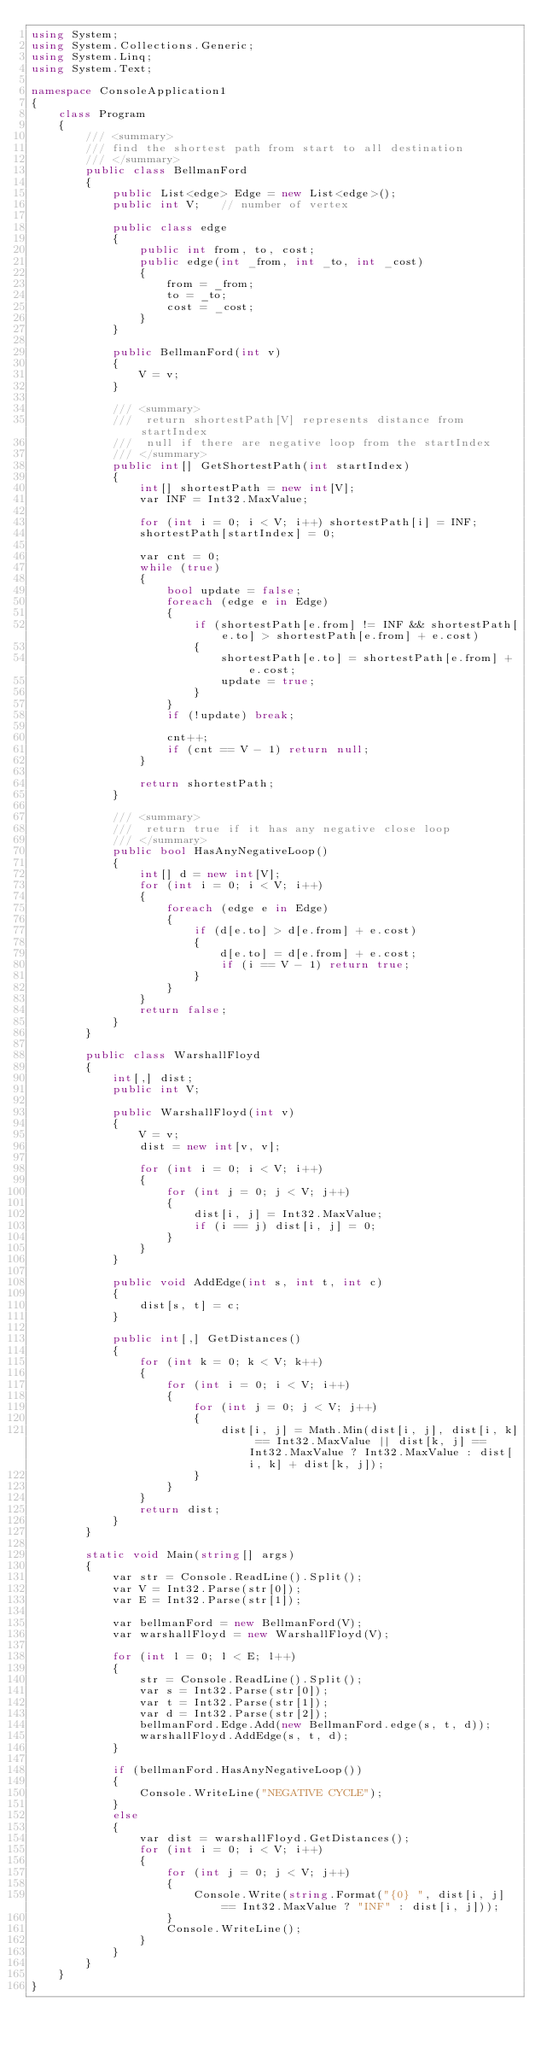<code> <loc_0><loc_0><loc_500><loc_500><_C#_>using System;
using System.Collections.Generic;
using System.Linq;
using System.Text;

namespace ConsoleApplication1
{
    class Program
    {
        /// <summary>
        /// find the shortest path from start to all destination
        /// </summary>
        public class BellmanFord
        {
            public List<edge> Edge = new List<edge>();
            public int V;   // number of vertex

            public class edge
            {
                public int from, to, cost;
                public edge(int _from, int _to, int _cost)
                {
                    from = _from;
                    to = _to;
                    cost = _cost;
                }
            }

            public BellmanFord(int v)
            {
                V = v;
            }

            /// <summary>
            ///  return shortestPath[V] represents distance from startIndex
            ///  null if there are negative loop from the startIndex
            /// </summary>
            public int[] GetShortestPath(int startIndex)
            {
                int[] shortestPath = new int[V];
                var INF = Int32.MaxValue;

                for (int i = 0; i < V; i++) shortestPath[i] = INF;
                shortestPath[startIndex] = 0;

                var cnt = 0;
                while (true)
                {
                    bool update = false;
                    foreach (edge e in Edge)
                    {
                        if (shortestPath[e.from] != INF && shortestPath[e.to] > shortestPath[e.from] + e.cost)
                        {
                            shortestPath[e.to] = shortestPath[e.from] + e.cost;
                            update = true;
                        }
                    }
                    if (!update) break;

                    cnt++;
                    if (cnt == V - 1) return null;
                }

                return shortestPath;
            }

            /// <summary>
            ///  return true if it has any negative close loop
            /// </summary>
            public bool HasAnyNegativeLoop()
            {
                int[] d = new int[V];
                for (int i = 0; i < V; i++)
                {
                    foreach (edge e in Edge)
                    {
                        if (d[e.to] > d[e.from] + e.cost)
                        {
                            d[e.to] = d[e.from] + e.cost;
                            if (i == V - 1) return true;
                        }
                    }
                }
                return false;
            }
        }

        public class WarshallFloyd
        {
            int[,] dist;
            public int V;

            public WarshallFloyd(int v)
            {
                V = v;
                dist = new int[v, v];

                for (int i = 0; i < V; i++)
                {
                    for (int j = 0; j < V; j++)
                    {
                        dist[i, j] = Int32.MaxValue;
                        if (i == j) dist[i, j] = 0;
                    }
                }
            }

            public void AddEdge(int s, int t, int c)
            {
                dist[s, t] = c;
            }

            public int[,] GetDistances()
            {
                for (int k = 0; k < V; k++)
                {
                    for (int i = 0; i < V; i++)
                    {
                        for (int j = 0; j < V; j++)
                        {
                            dist[i, j] = Math.Min(dist[i, j], dist[i, k] == Int32.MaxValue || dist[k, j] == Int32.MaxValue ? Int32.MaxValue : dist[i, k] + dist[k, j]);
                        }
                    }
                }
                return dist;
            }
        }

        static void Main(string[] args)
        {
            var str = Console.ReadLine().Split();
            var V = Int32.Parse(str[0]);
            var E = Int32.Parse(str[1]);

            var bellmanFord = new BellmanFord(V);
            var warshallFloyd = new WarshallFloyd(V);

            for (int l = 0; l < E; l++)
            {
                str = Console.ReadLine().Split();
                var s = Int32.Parse(str[0]);
                var t = Int32.Parse(str[1]);
                var d = Int32.Parse(str[2]);
                bellmanFord.Edge.Add(new BellmanFord.edge(s, t, d));
                warshallFloyd.AddEdge(s, t, d);
            }

            if (bellmanFord.HasAnyNegativeLoop())
            {
                Console.WriteLine("NEGATIVE CYCLE");
            }
            else
            {
                var dist = warshallFloyd.GetDistances();
                for (int i = 0; i < V; i++)
                {
                    for (int j = 0; j < V; j++)
                    {
                        Console.Write(string.Format("{0} ", dist[i, j] == Int32.MaxValue ? "INF" : dist[i, j]));
                    }
                    Console.WriteLine();
                }
            }
        }
    }
}</code> 